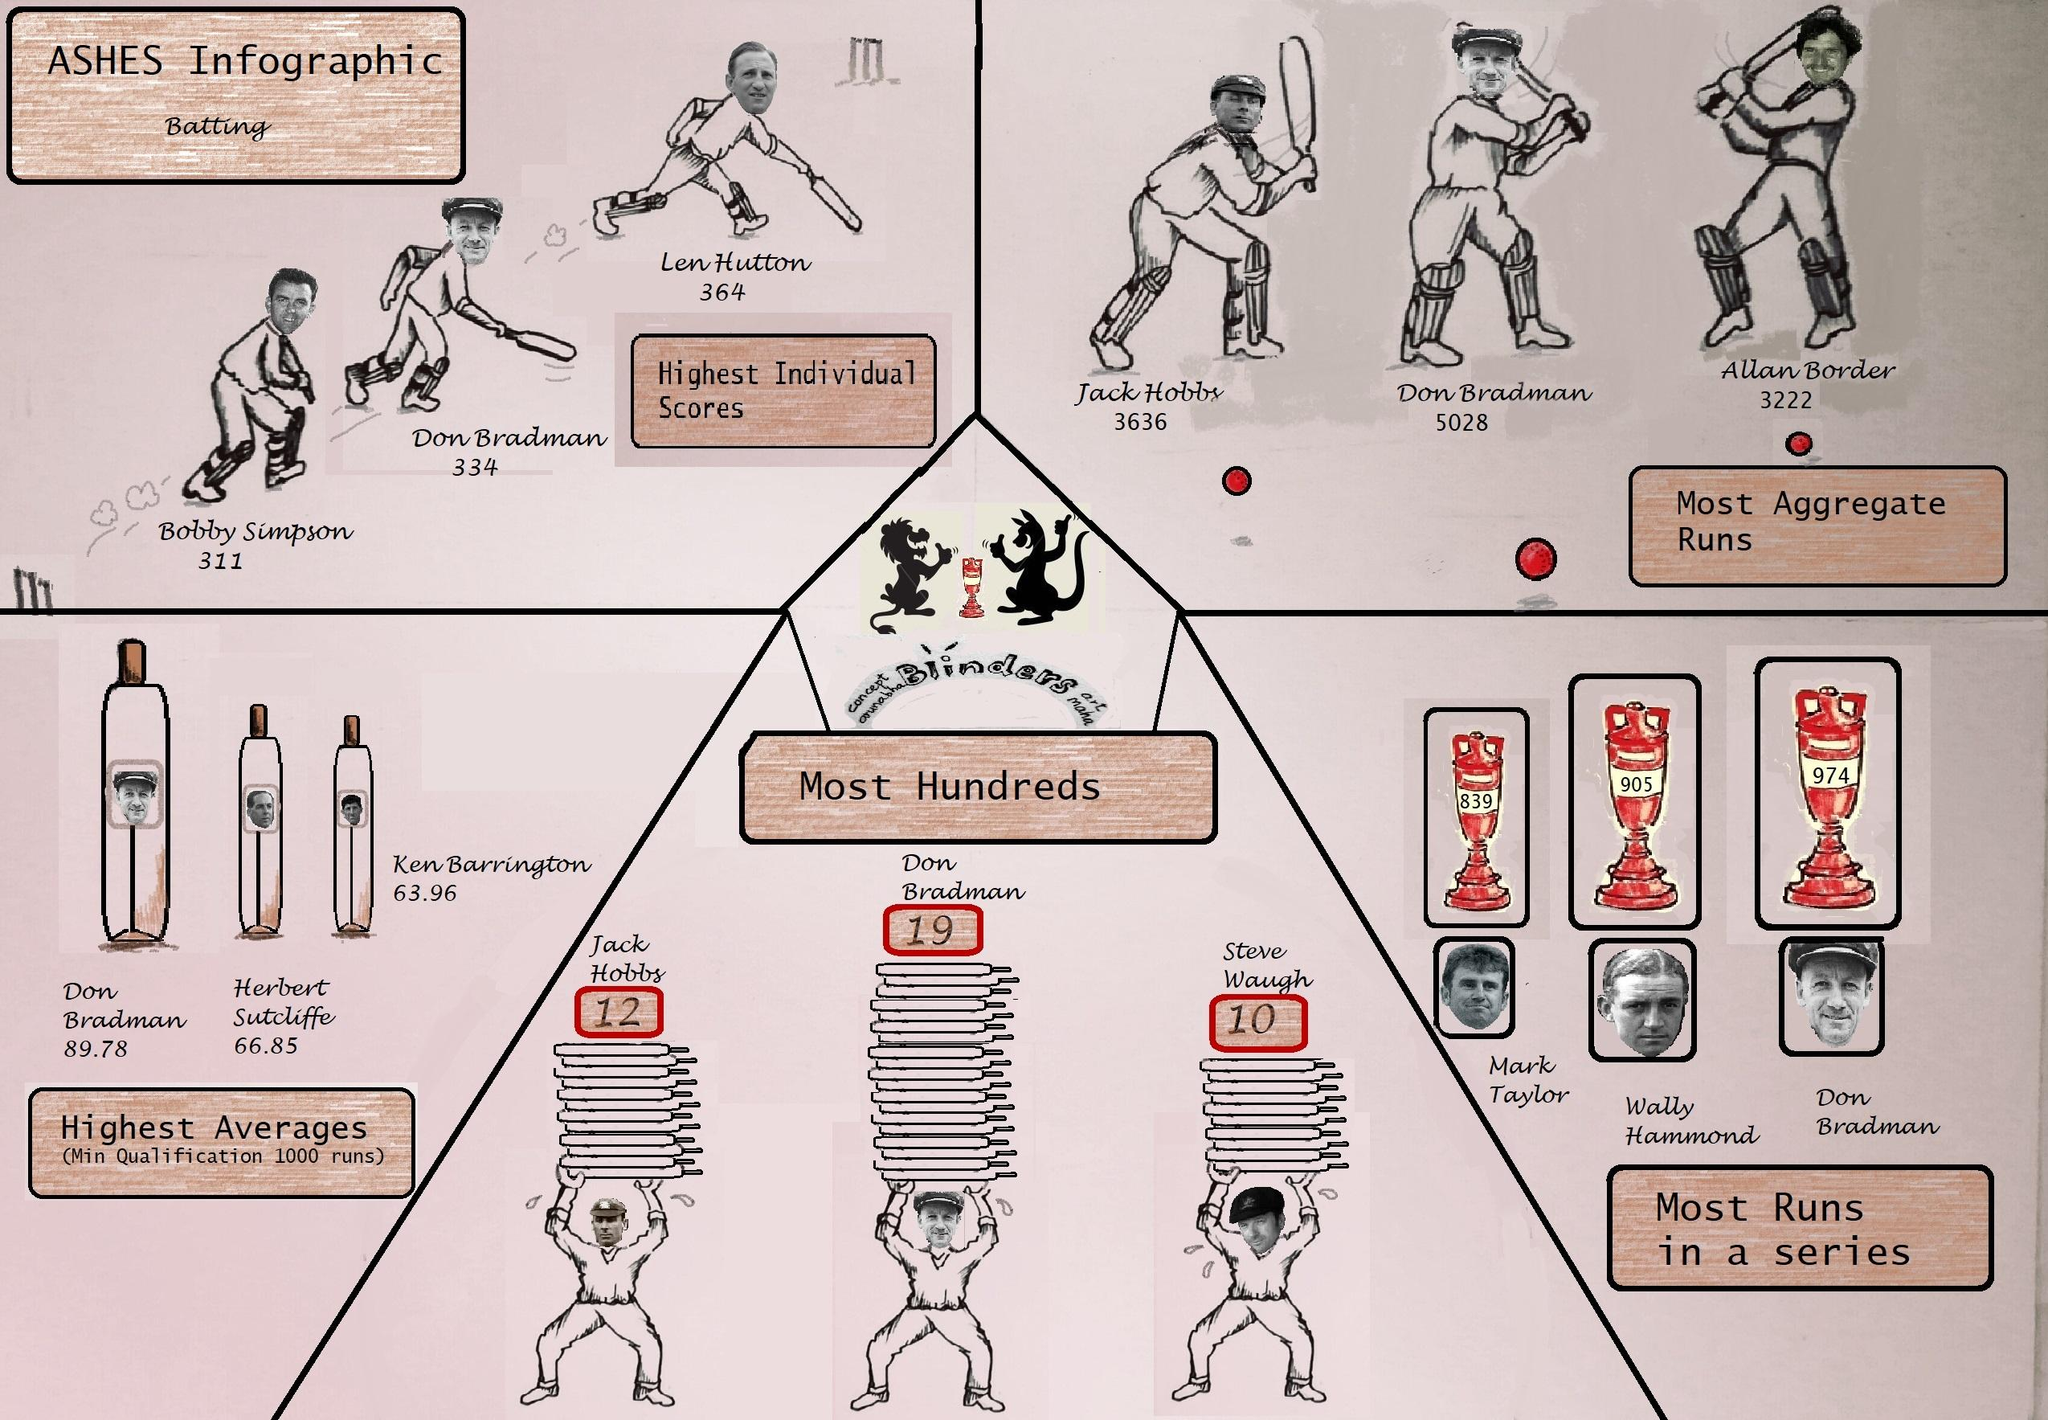Highlight a few significant elements in this photo. In a record-breaking performance, Don Bradman posted the second-highest individual score, cementing his status as a cricketing legend. Len Hutton holds the record for the highest individual score in cricket history. It is Don Bradman who holds the highest number of hundreds. The second-highest individual score is 334. The second most aggregate run is 3636... 